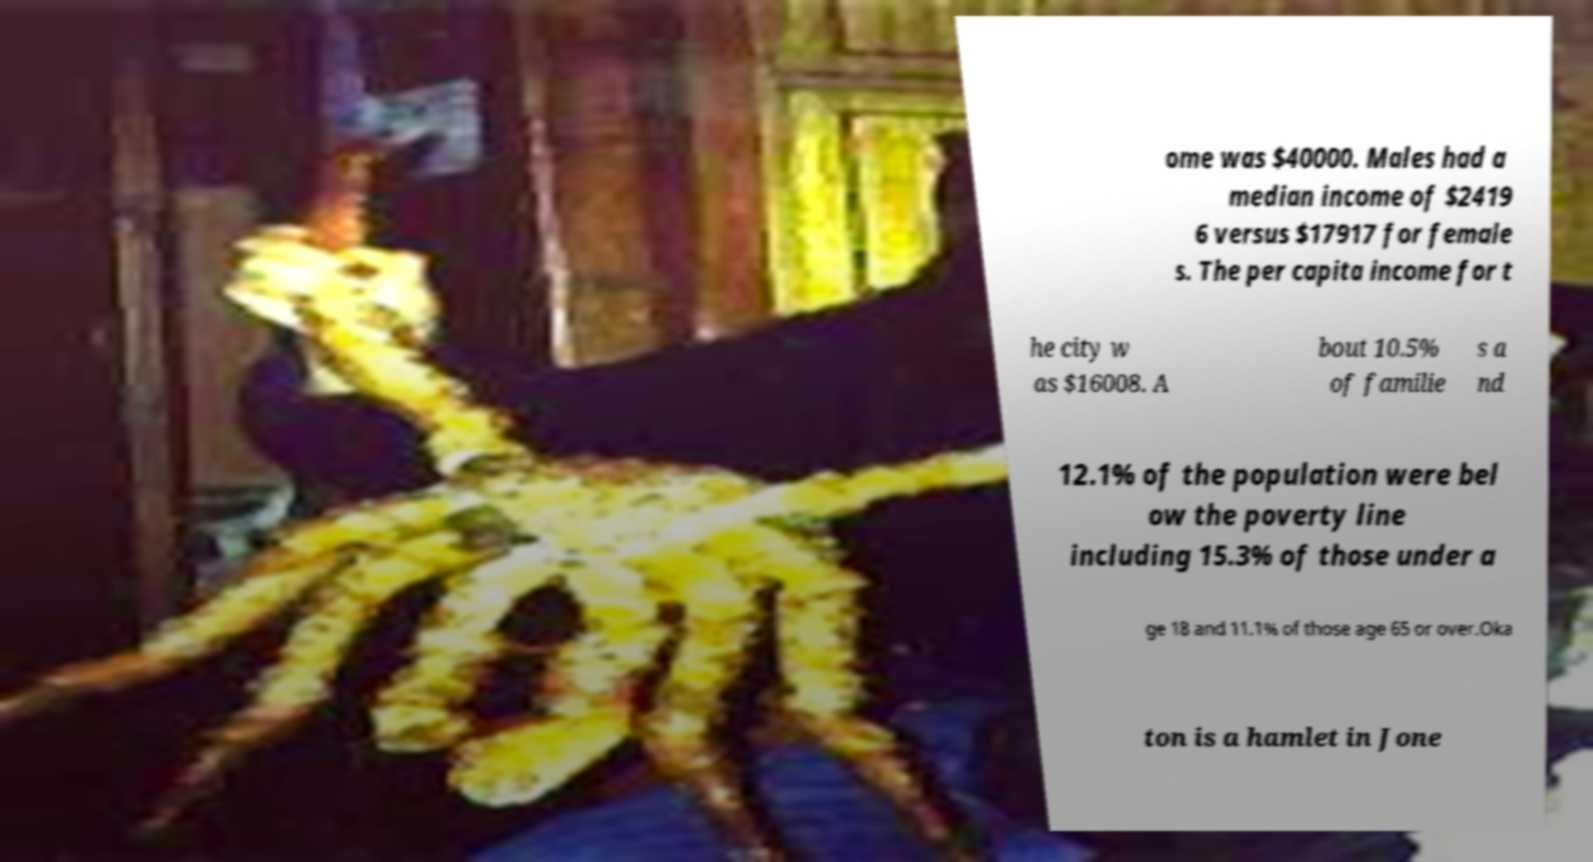What messages or text are displayed in this image? I need them in a readable, typed format. ome was $40000. Males had a median income of $2419 6 versus $17917 for female s. The per capita income for t he city w as $16008. A bout 10.5% of familie s a nd 12.1% of the population were bel ow the poverty line including 15.3% of those under a ge 18 and 11.1% of those age 65 or over.Oka ton is a hamlet in Jone 